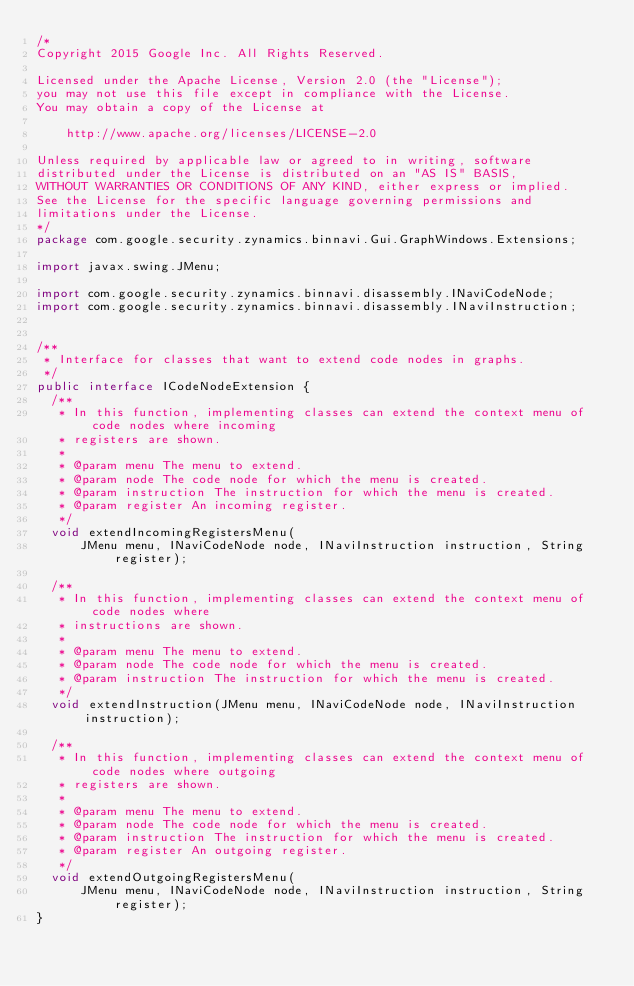<code> <loc_0><loc_0><loc_500><loc_500><_Java_>/*
Copyright 2015 Google Inc. All Rights Reserved.

Licensed under the Apache License, Version 2.0 (the "License");
you may not use this file except in compliance with the License.
You may obtain a copy of the License at

    http://www.apache.org/licenses/LICENSE-2.0

Unless required by applicable law or agreed to in writing, software
distributed under the License is distributed on an "AS IS" BASIS,
WITHOUT WARRANTIES OR CONDITIONS OF ANY KIND, either express or implied.
See the License for the specific language governing permissions and
limitations under the License.
*/
package com.google.security.zynamics.binnavi.Gui.GraphWindows.Extensions;

import javax.swing.JMenu;

import com.google.security.zynamics.binnavi.disassembly.INaviCodeNode;
import com.google.security.zynamics.binnavi.disassembly.INaviInstruction;


/**
 * Interface for classes that want to extend code nodes in graphs.
 */
public interface ICodeNodeExtension {
  /**
   * In this function, implementing classes can extend the context menu of code nodes where incoming
   * registers are shown.
   *
   * @param menu The menu to extend.
   * @param node The code node for which the menu is created.
   * @param instruction The instruction for which the menu is created.
   * @param register An incoming register.
   */
  void extendIncomingRegistersMenu(
      JMenu menu, INaviCodeNode node, INaviInstruction instruction, String register);

  /**
   * In this function, implementing classes can extend the context menu of code nodes where
   * instructions are shown.
   *
   * @param menu The menu to extend.
   * @param node The code node for which the menu is created.
   * @param instruction The instruction for which the menu is created.
   */
  void extendInstruction(JMenu menu, INaviCodeNode node, INaviInstruction instruction);

  /**
   * In this function, implementing classes can extend the context menu of code nodes where outgoing
   * registers are shown.
   *
   * @param menu The menu to extend.
   * @param node The code node for which the menu is created.
   * @param instruction The instruction for which the menu is created.
   * @param register An outgoing register.
   */
  void extendOutgoingRegistersMenu(
      JMenu menu, INaviCodeNode node, INaviInstruction instruction, String register);
}
</code> 